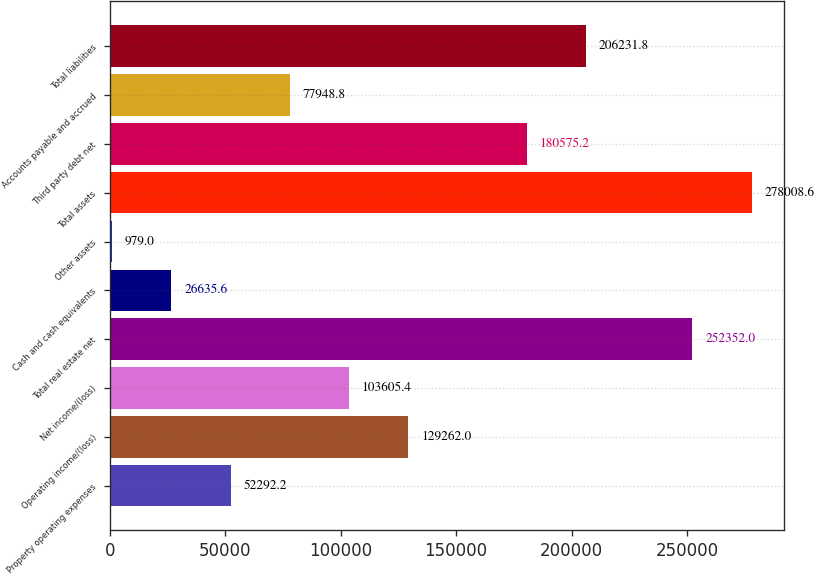<chart> <loc_0><loc_0><loc_500><loc_500><bar_chart><fcel>Property operating expenses<fcel>Operating income/(loss)<fcel>Net income/(loss)<fcel>Total real estate net<fcel>Cash and cash equivalents<fcel>Other assets<fcel>Total assets<fcel>Third party debt net<fcel>Accounts payable and accrued<fcel>Total liabilities<nl><fcel>52292.2<fcel>129262<fcel>103605<fcel>252352<fcel>26635.6<fcel>979<fcel>278009<fcel>180575<fcel>77948.8<fcel>206232<nl></chart> 